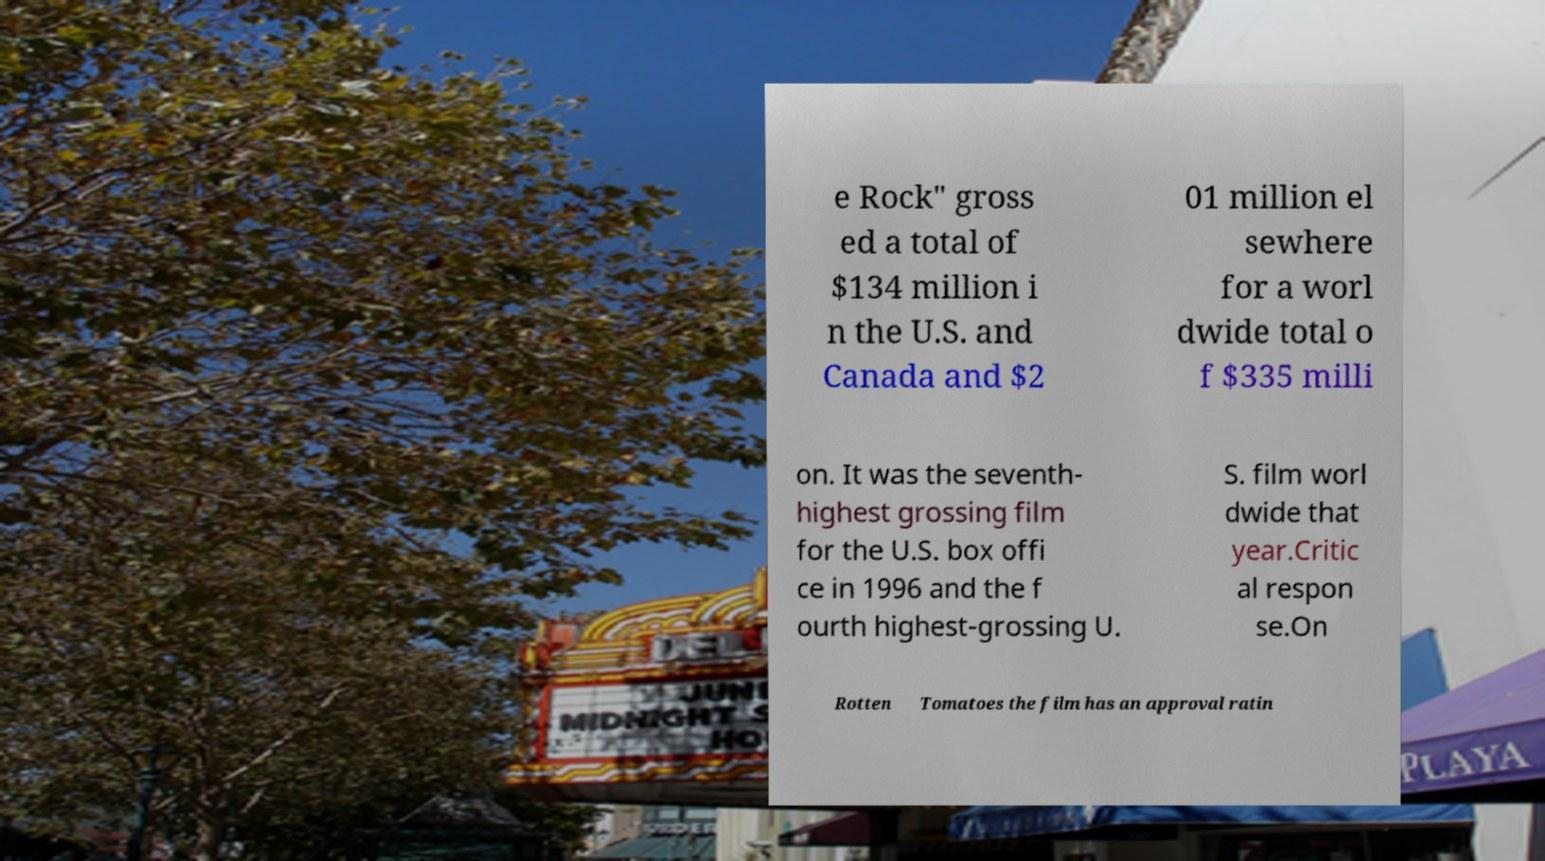Could you assist in decoding the text presented in this image and type it out clearly? e Rock" gross ed a total of $134 million i n the U.S. and Canada and $2 01 million el sewhere for a worl dwide total o f $335 milli on. It was the seventh- highest grossing film for the U.S. box offi ce in 1996 and the f ourth highest-grossing U. S. film worl dwide that year.Critic al respon se.On Rotten Tomatoes the film has an approval ratin 